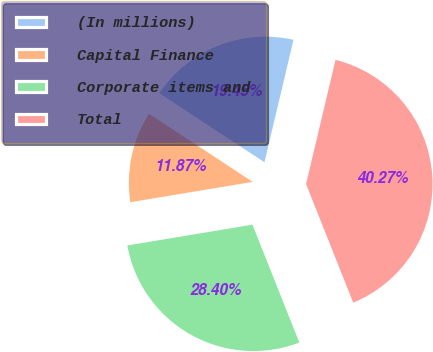Convert chart to OTSL. <chart><loc_0><loc_0><loc_500><loc_500><pie_chart><fcel>(In millions)<fcel>Capital Finance<fcel>Corporate items and<fcel>Total<nl><fcel>19.45%<fcel>11.87%<fcel>28.4%<fcel>40.27%<nl></chart> 